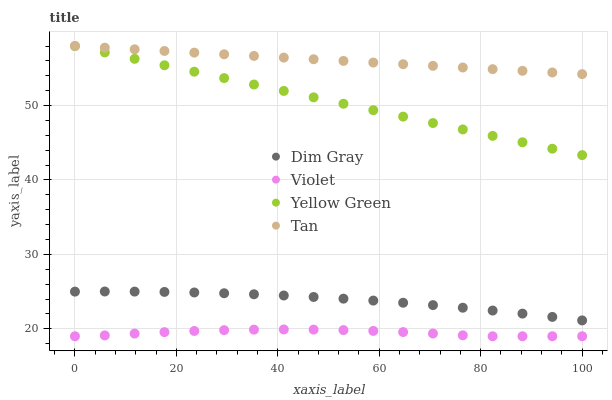Does Violet have the minimum area under the curve?
Answer yes or no. Yes. Does Tan have the maximum area under the curve?
Answer yes or no. Yes. Does Dim Gray have the minimum area under the curve?
Answer yes or no. No. Does Dim Gray have the maximum area under the curve?
Answer yes or no. No. Is Tan the smoothest?
Answer yes or no. Yes. Is Violet the roughest?
Answer yes or no. Yes. Is Dim Gray the smoothest?
Answer yes or no. No. Is Dim Gray the roughest?
Answer yes or no. No. Does Violet have the lowest value?
Answer yes or no. Yes. Does Dim Gray have the lowest value?
Answer yes or no. No. Does Yellow Green have the highest value?
Answer yes or no. Yes. Does Dim Gray have the highest value?
Answer yes or no. No. Is Violet less than Yellow Green?
Answer yes or no. Yes. Is Yellow Green greater than Violet?
Answer yes or no. Yes. Does Yellow Green intersect Tan?
Answer yes or no. Yes. Is Yellow Green less than Tan?
Answer yes or no. No. Is Yellow Green greater than Tan?
Answer yes or no. No. Does Violet intersect Yellow Green?
Answer yes or no. No. 